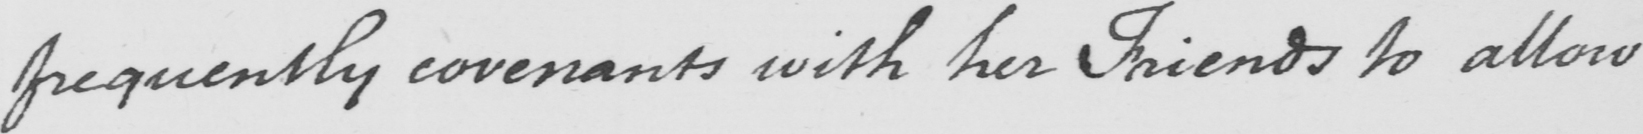What does this handwritten line say? frequently covenants with her Friends to allow 